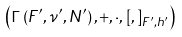<formula> <loc_0><loc_0><loc_500><loc_500>\left ( \Gamma \left ( F ^ { \prime } , \nu ^ { \prime } , N ^ { \prime } \right ) , + , \cdot , \left [ , \right ] _ { F ^ { \prime } , h ^ { \prime } } \right )</formula> 